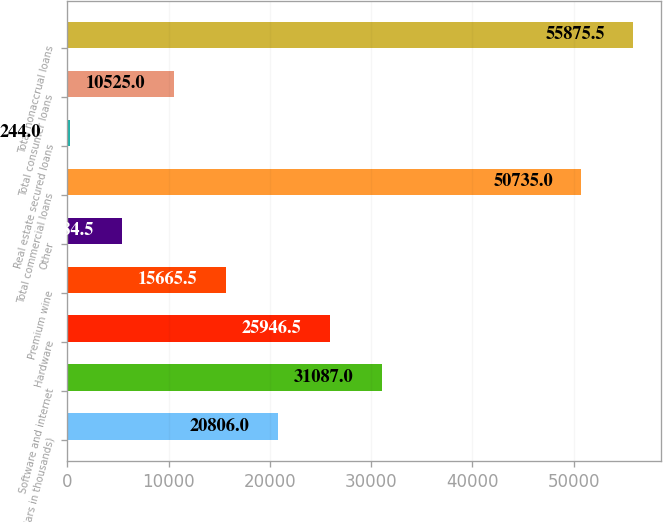<chart> <loc_0><loc_0><loc_500><loc_500><bar_chart><fcel>(Dollars in thousands)<fcel>Software and internet<fcel>Hardware<fcel>Premium wine<fcel>Other<fcel>Total commercial loans<fcel>Real estate secured loans<fcel>Total consumer loans<fcel>Total nonaccrual loans<nl><fcel>20806<fcel>31087<fcel>25946.5<fcel>15665.5<fcel>5384.5<fcel>50735<fcel>244<fcel>10525<fcel>55875.5<nl></chart> 